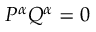<formula> <loc_0><loc_0><loc_500><loc_500>P ^ { \alpha } Q ^ { \alpha } = 0</formula> 